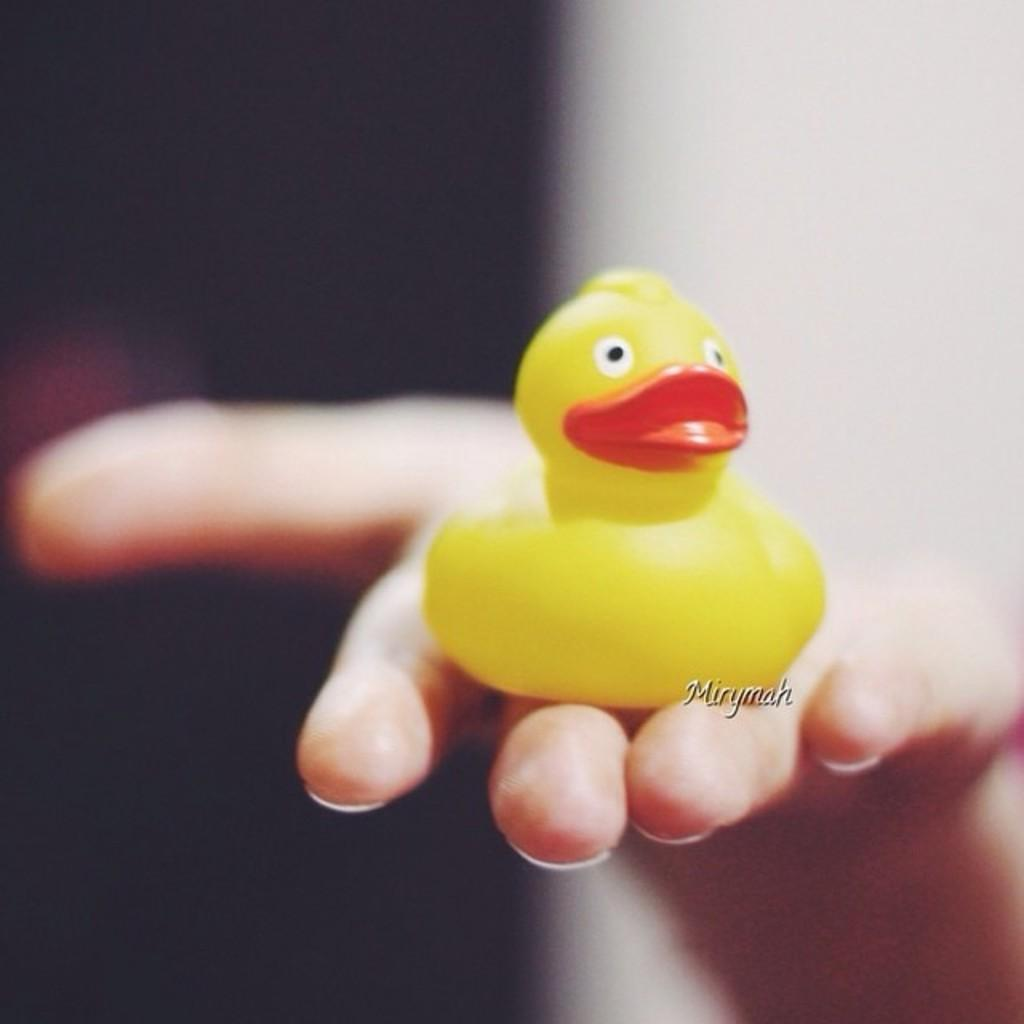What object can be seen in the image? There is a toy in the image. Where is the toy located in relation to the person? The toy is on the hand of a person. What is the position of the person in the image? The person is in the center of the image. How would you describe the background of the image? The background of the image is blurry. What type of insurance does the person in the image have? There is no information about insurance in the image, as it focuses on a toy and a person holding it. 